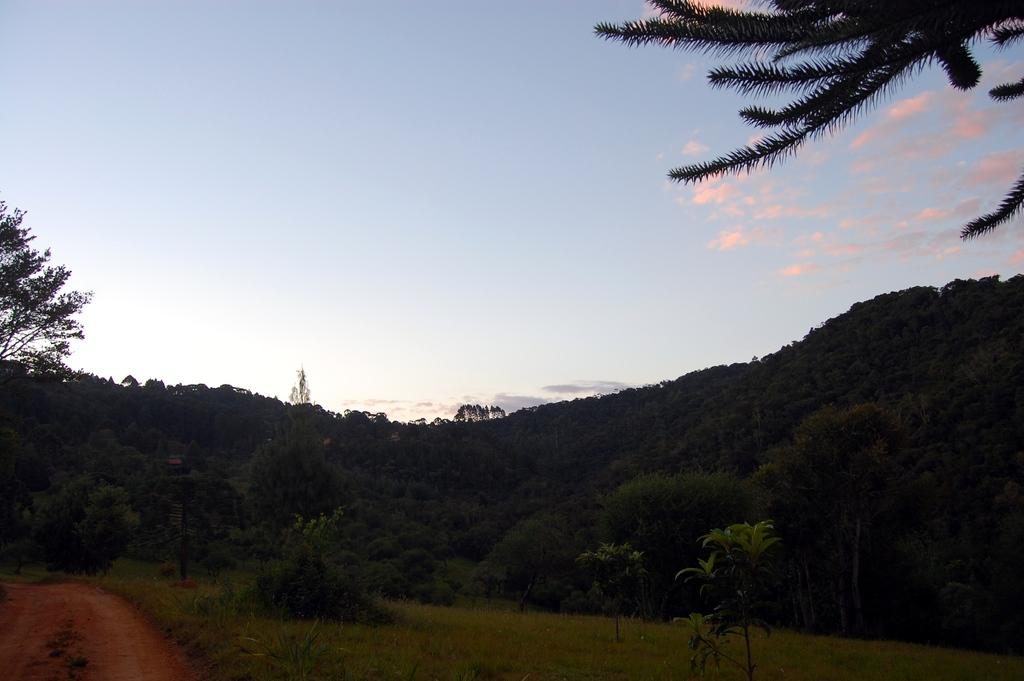What type of vegetation can be seen in the image? There are plants and trees in the image. What part of the natural environment is visible in the image? The sky is visible in the image. How many cattle can be seen grazing in the image? There are no cattle present in the image. What type of tongue can be seen in the image? There is no tongue present in the image. 